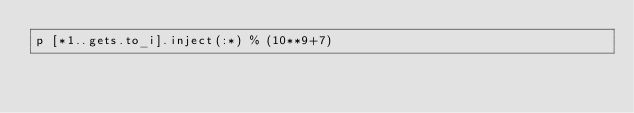Convert code to text. <code><loc_0><loc_0><loc_500><loc_500><_Ruby_>p [*1..gets.to_i].inject(:*) % (10**9+7)</code> 